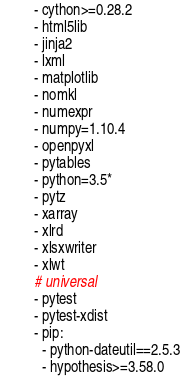Convert code to text. <code><loc_0><loc_0><loc_500><loc_500><_YAML_>  - cython>=0.28.2
  - html5lib
  - jinja2
  - lxml
  - matplotlib
  - nomkl
  - numexpr
  - numpy=1.10.4
  - openpyxl
  - pytables
  - python=3.5*
  - pytz
  - xarray
  - xlrd
  - xlsxwriter
  - xlwt
  # universal
  - pytest
  - pytest-xdist
  - pip:
    - python-dateutil==2.5.3
    - hypothesis>=3.58.0
</code> 